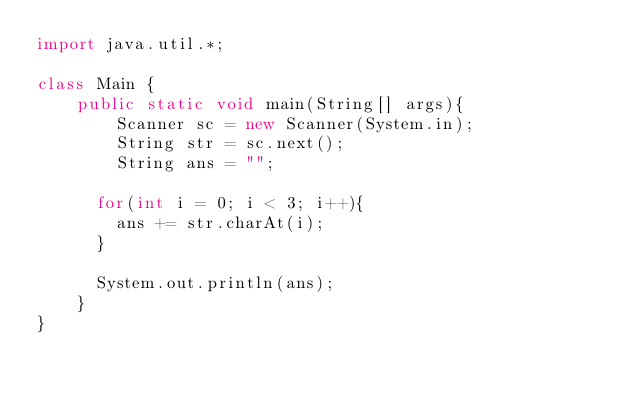Convert code to text. <code><loc_0><loc_0><loc_500><loc_500><_Java_>import java.util.*;

class Main {
	public static void main(String[] args){
		Scanner sc = new Scanner(System.in);
      	String str = sc.next();
     	String ans = "";
      
      for(int i = 0; i < 3; i++){
      	ans += str.charAt(i);
      }  
      
      System.out.println(ans);
    } 
}</code> 